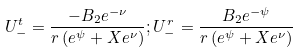<formula> <loc_0><loc_0><loc_500><loc_500>U ^ { t } _ { - } = \frac { - B _ { 2 } e ^ { - \nu } } { r \left ( e ^ { \psi } + X e ^ { \nu } \right ) } ; U ^ { r } _ { - } = \frac { B _ { 2 } e ^ { - \psi } } { r \left ( e ^ { \psi } + X e ^ { \nu } \right ) }</formula> 